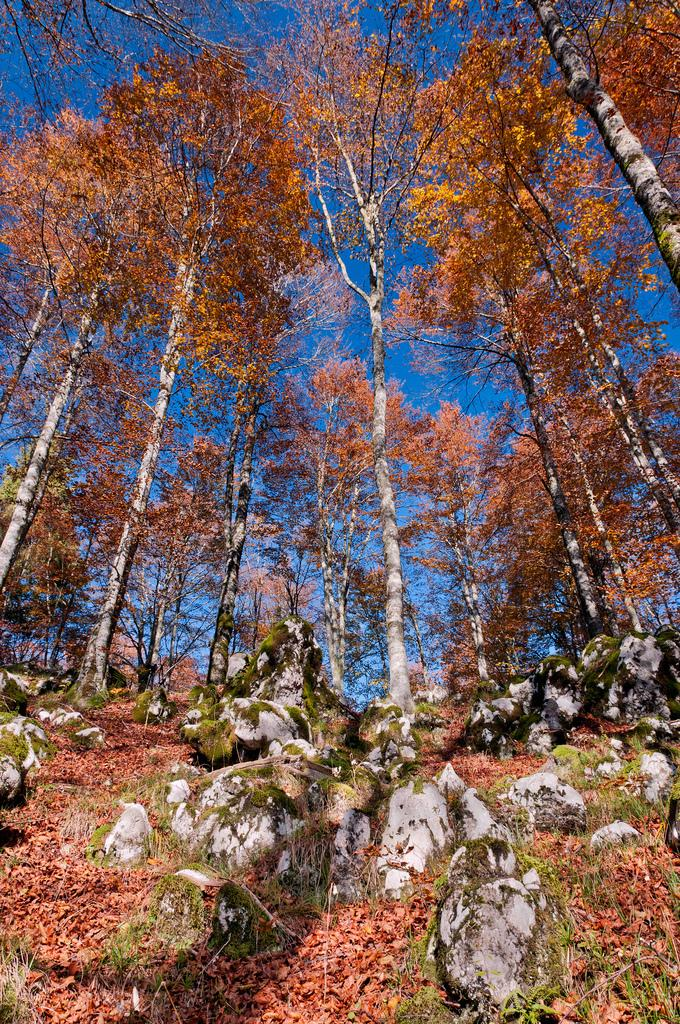What type of vegetation can be seen in the image? There are trees in the image. What can be found on the ground in the image? There are rocks on the ground in the image. What else is present on the land in the image? Dried leaves are present on the land. What is visible in the background of the image? There is sky visible in the background of the image. What type of feast is being held under the trees in the image? There is no indication of a feast or gathering in the image; it simply shows trees, rocks, dried leaves, and sky. How hot is the weather in the image? The image does not provide any information about the temperature or weather conditions. 